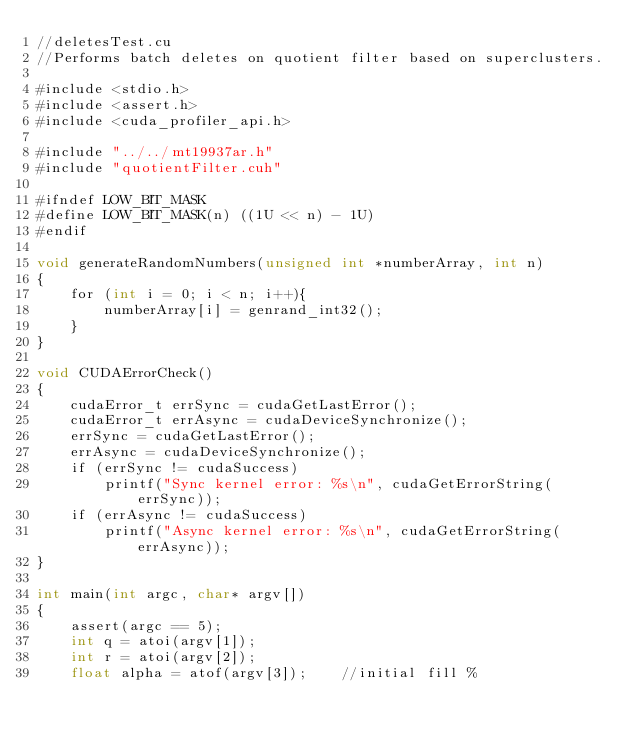<code> <loc_0><loc_0><loc_500><loc_500><_Cuda_>//deletesTest.cu
//Performs batch deletes on quotient filter based on superclusters.

#include <stdio.h>
#include <assert.h>
#include <cuda_profiler_api.h>

#include "../../mt19937ar.h"
#include "quotientFilter.cuh"

#ifndef LOW_BIT_MASK
#define LOW_BIT_MASK(n) ((1U << n) - 1U)
#endif

void generateRandomNumbers(unsigned int *numberArray, int n)
{
    for (int i = 0; i < n; i++){
        numberArray[i] = genrand_int32();
    }
}

void CUDAErrorCheck()
{
    cudaError_t errSync = cudaGetLastError();
    cudaError_t errAsync = cudaDeviceSynchronize();
    errSync = cudaGetLastError();
    errAsync = cudaDeviceSynchronize();
    if (errSync != cudaSuccess)
        printf("Sync kernel error: %s\n", cudaGetErrorString(errSync));
    if (errAsync != cudaSuccess)
        printf("Async kernel error: %s\n", cudaGetErrorString(errAsync));
}

int main(int argc, char* argv[])
{
    assert(argc == 5);
    int q = atoi(argv[1]);
    int r = atoi(argv[2]);
    float alpha = atof(argv[3]);    //initial fill %</code> 